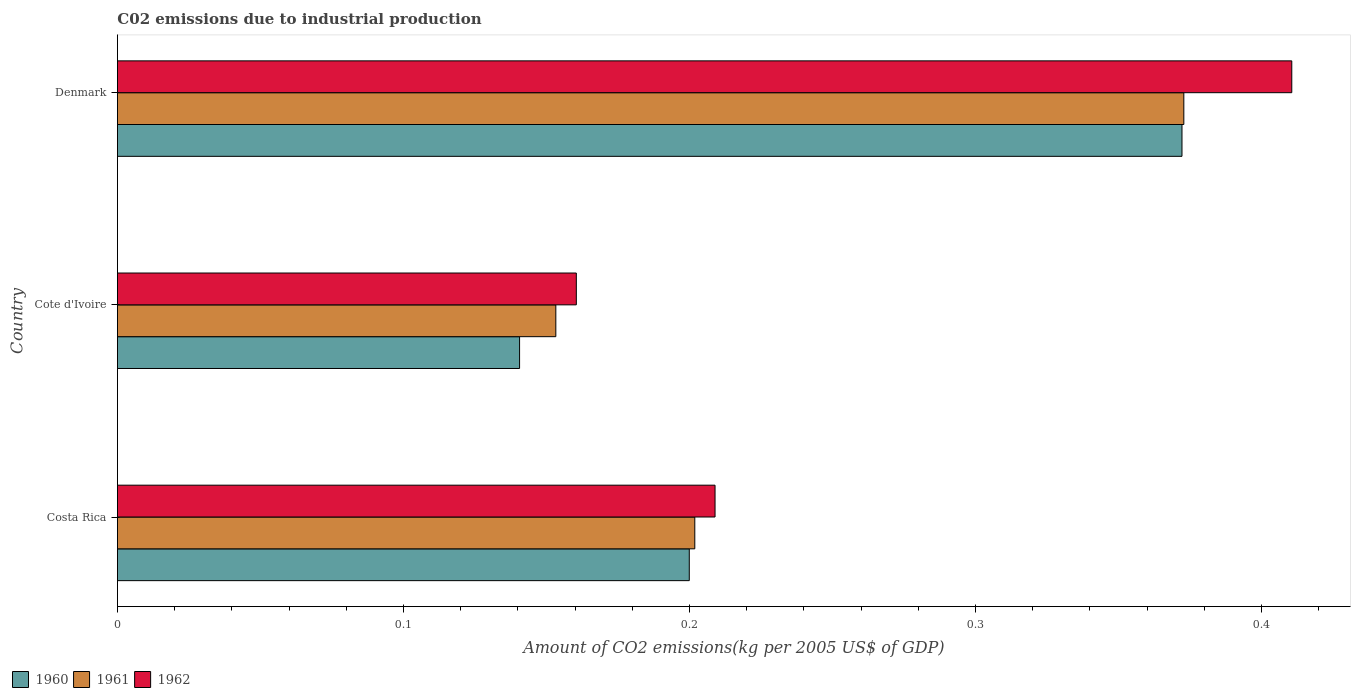How many different coloured bars are there?
Your response must be concise. 3. How many bars are there on the 1st tick from the top?
Ensure brevity in your answer.  3. In how many cases, is the number of bars for a given country not equal to the number of legend labels?
Ensure brevity in your answer.  0. What is the amount of CO2 emitted due to industrial production in 1962 in Cote d'Ivoire?
Make the answer very short. 0.16. Across all countries, what is the maximum amount of CO2 emitted due to industrial production in 1962?
Ensure brevity in your answer.  0.41. Across all countries, what is the minimum amount of CO2 emitted due to industrial production in 1960?
Your answer should be compact. 0.14. In which country was the amount of CO2 emitted due to industrial production in 1962 minimum?
Your response must be concise. Cote d'Ivoire. What is the total amount of CO2 emitted due to industrial production in 1960 in the graph?
Provide a short and direct response. 0.71. What is the difference between the amount of CO2 emitted due to industrial production in 1960 in Costa Rica and that in Denmark?
Provide a short and direct response. -0.17. What is the difference between the amount of CO2 emitted due to industrial production in 1960 in Cote d'Ivoire and the amount of CO2 emitted due to industrial production in 1962 in Costa Rica?
Offer a terse response. -0.07. What is the average amount of CO2 emitted due to industrial production in 1960 per country?
Your answer should be very brief. 0.24. What is the difference between the amount of CO2 emitted due to industrial production in 1962 and amount of CO2 emitted due to industrial production in 1960 in Denmark?
Offer a very short reply. 0.04. What is the ratio of the amount of CO2 emitted due to industrial production in 1960 in Cote d'Ivoire to that in Denmark?
Make the answer very short. 0.38. Is the difference between the amount of CO2 emitted due to industrial production in 1962 in Costa Rica and Denmark greater than the difference between the amount of CO2 emitted due to industrial production in 1960 in Costa Rica and Denmark?
Provide a succinct answer. No. What is the difference between the highest and the second highest amount of CO2 emitted due to industrial production in 1961?
Make the answer very short. 0.17. What is the difference between the highest and the lowest amount of CO2 emitted due to industrial production in 1960?
Your answer should be compact. 0.23. In how many countries, is the amount of CO2 emitted due to industrial production in 1960 greater than the average amount of CO2 emitted due to industrial production in 1960 taken over all countries?
Provide a succinct answer. 1. Is it the case that in every country, the sum of the amount of CO2 emitted due to industrial production in 1960 and amount of CO2 emitted due to industrial production in 1961 is greater than the amount of CO2 emitted due to industrial production in 1962?
Offer a terse response. Yes. How many bars are there?
Ensure brevity in your answer.  9. How many countries are there in the graph?
Give a very brief answer. 3. What is the difference between two consecutive major ticks on the X-axis?
Your response must be concise. 0.1. Does the graph contain any zero values?
Offer a very short reply. No. Does the graph contain grids?
Offer a very short reply. No. Where does the legend appear in the graph?
Provide a short and direct response. Bottom left. How are the legend labels stacked?
Ensure brevity in your answer.  Horizontal. What is the title of the graph?
Provide a short and direct response. C02 emissions due to industrial production. Does "1971" appear as one of the legend labels in the graph?
Give a very brief answer. No. What is the label or title of the X-axis?
Ensure brevity in your answer.  Amount of CO2 emissions(kg per 2005 US$ of GDP). What is the label or title of the Y-axis?
Make the answer very short. Country. What is the Amount of CO2 emissions(kg per 2005 US$ of GDP) of 1960 in Costa Rica?
Provide a succinct answer. 0.2. What is the Amount of CO2 emissions(kg per 2005 US$ of GDP) in 1961 in Costa Rica?
Your answer should be compact. 0.2. What is the Amount of CO2 emissions(kg per 2005 US$ of GDP) in 1962 in Costa Rica?
Your response must be concise. 0.21. What is the Amount of CO2 emissions(kg per 2005 US$ of GDP) in 1960 in Cote d'Ivoire?
Make the answer very short. 0.14. What is the Amount of CO2 emissions(kg per 2005 US$ of GDP) in 1961 in Cote d'Ivoire?
Your answer should be compact. 0.15. What is the Amount of CO2 emissions(kg per 2005 US$ of GDP) of 1962 in Cote d'Ivoire?
Keep it short and to the point. 0.16. What is the Amount of CO2 emissions(kg per 2005 US$ of GDP) of 1960 in Denmark?
Offer a terse response. 0.37. What is the Amount of CO2 emissions(kg per 2005 US$ of GDP) of 1961 in Denmark?
Your response must be concise. 0.37. What is the Amount of CO2 emissions(kg per 2005 US$ of GDP) in 1962 in Denmark?
Make the answer very short. 0.41. Across all countries, what is the maximum Amount of CO2 emissions(kg per 2005 US$ of GDP) of 1960?
Offer a very short reply. 0.37. Across all countries, what is the maximum Amount of CO2 emissions(kg per 2005 US$ of GDP) of 1961?
Give a very brief answer. 0.37. Across all countries, what is the maximum Amount of CO2 emissions(kg per 2005 US$ of GDP) in 1962?
Offer a very short reply. 0.41. Across all countries, what is the minimum Amount of CO2 emissions(kg per 2005 US$ of GDP) in 1960?
Ensure brevity in your answer.  0.14. Across all countries, what is the minimum Amount of CO2 emissions(kg per 2005 US$ of GDP) of 1961?
Provide a succinct answer. 0.15. Across all countries, what is the minimum Amount of CO2 emissions(kg per 2005 US$ of GDP) of 1962?
Provide a succinct answer. 0.16. What is the total Amount of CO2 emissions(kg per 2005 US$ of GDP) of 1960 in the graph?
Give a very brief answer. 0.71. What is the total Amount of CO2 emissions(kg per 2005 US$ of GDP) of 1961 in the graph?
Keep it short and to the point. 0.73. What is the total Amount of CO2 emissions(kg per 2005 US$ of GDP) of 1962 in the graph?
Offer a very short reply. 0.78. What is the difference between the Amount of CO2 emissions(kg per 2005 US$ of GDP) of 1960 in Costa Rica and that in Cote d'Ivoire?
Provide a succinct answer. 0.06. What is the difference between the Amount of CO2 emissions(kg per 2005 US$ of GDP) in 1961 in Costa Rica and that in Cote d'Ivoire?
Provide a short and direct response. 0.05. What is the difference between the Amount of CO2 emissions(kg per 2005 US$ of GDP) of 1962 in Costa Rica and that in Cote d'Ivoire?
Your answer should be very brief. 0.05. What is the difference between the Amount of CO2 emissions(kg per 2005 US$ of GDP) of 1960 in Costa Rica and that in Denmark?
Ensure brevity in your answer.  -0.17. What is the difference between the Amount of CO2 emissions(kg per 2005 US$ of GDP) of 1961 in Costa Rica and that in Denmark?
Keep it short and to the point. -0.17. What is the difference between the Amount of CO2 emissions(kg per 2005 US$ of GDP) of 1962 in Costa Rica and that in Denmark?
Make the answer very short. -0.2. What is the difference between the Amount of CO2 emissions(kg per 2005 US$ of GDP) in 1960 in Cote d'Ivoire and that in Denmark?
Your answer should be very brief. -0.23. What is the difference between the Amount of CO2 emissions(kg per 2005 US$ of GDP) in 1961 in Cote d'Ivoire and that in Denmark?
Make the answer very short. -0.22. What is the difference between the Amount of CO2 emissions(kg per 2005 US$ of GDP) in 1962 in Cote d'Ivoire and that in Denmark?
Your answer should be very brief. -0.25. What is the difference between the Amount of CO2 emissions(kg per 2005 US$ of GDP) in 1960 in Costa Rica and the Amount of CO2 emissions(kg per 2005 US$ of GDP) in 1961 in Cote d'Ivoire?
Provide a short and direct response. 0.05. What is the difference between the Amount of CO2 emissions(kg per 2005 US$ of GDP) in 1960 in Costa Rica and the Amount of CO2 emissions(kg per 2005 US$ of GDP) in 1962 in Cote d'Ivoire?
Provide a succinct answer. 0.04. What is the difference between the Amount of CO2 emissions(kg per 2005 US$ of GDP) of 1961 in Costa Rica and the Amount of CO2 emissions(kg per 2005 US$ of GDP) of 1962 in Cote d'Ivoire?
Give a very brief answer. 0.04. What is the difference between the Amount of CO2 emissions(kg per 2005 US$ of GDP) in 1960 in Costa Rica and the Amount of CO2 emissions(kg per 2005 US$ of GDP) in 1961 in Denmark?
Give a very brief answer. -0.17. What is the difference between the Amount of CO2 emissions(kg per 2005 US$ of GDP) in 1960 in Costa Rica and the Amount of CO2 emissions(kg per 2005 US$ of GDP) in 1962 in Denmark?
Provide a succinct answer. -0.21. What is the difference between the Amount of CO2 emissions(kg per 2005 US$ of GDP) of 1961 in Costa Rica and the Amount of CO2 emissions(kg per 2005 US$ of GDP) of 1962 in Denmark?
Offer a very short reply. -0.21. What is the difference between the Amount of CO2 emissions(kg per 2005 US$ of GDP) of 1960 in Cote d'Ivoire and the Amount of CO2 emissions(kg per 2005 US$ of GDP) of 1961 in Denmark?
Provide a short and direct response. -0.23. What is the difference between the Amount of CO2 emissions(kg per 2005 US$ of GDP) of 1960 in Cote d'Ivoire and the Amount of CO2 emissions(kg per 2005 US$ of GDP) of 1962 in Denmark?
Offer a terse response. -0.27. What is the difference between the Amount of CO2 emissions(kg per 2005 US$ of GDP) of 1961 in Cote d'Ivoire and the Amount of CO2 emissions(kg per 2005 US$ of GDP) of 1962 in Denmark?
Give a very brief answer. -0.26. What is the average Amount of CO2 emissions(kg per 2005 US$ of GDP) in 1960 per country?
Offer a terse response. 0.24. What is the average Amount of CO2 emissions(kg per 2005 US$ of GDP) of 1961 per country?
Your answer should be compact. 0.24. What is the average Amount of CO2 emissions(kg per 2005 US$ of GDP) in 1962 per country?
Your response must be concise. 0.26. What is the difference between the Amount of CO2 emissions(kg per 2005 US$ of GDP) of 1960 and Amount of CO2 emissions(kg per 2005 US$ of GDP) of 1961 in Costa Rica?
Offer a very short reply. -0. What is the difference between the Amount of CO2 emissions(kg per 2005 US$ of GDP) in 1960 and Amount of CO2 emissions(kg per 2005 US$ of GDP) in 1962 in Costa Rica?
Keep it short and to the point. -0.01. What is the difference between the Amount of CO2 emissions(kg per 2005 US$ of GDP) in 1961 and Amount of CO2 emissions(kg per 2005 US$ of GDP) in 1962 in Costa Rica?
Keep it short and to the point. -0.01. What is the difference between the Amount of CO2 emissions(kg per 2005 US$ of GDP) of 1960 and Amount of CO2 emissions(kg per 2005 US$ of GDP) of 1961 in Cote d'Ivoire?
Your response must be concise. -0.01. What is the difference between the Amount of CO2 emissions(kg per 2005 US$ of GDP) of 1960 and Amount of CO2 emissions(kg per 2005 US$ of GDP) of 1962 in Cote d'Ivoire?
Provide a succinct answer. -0.02. What is the difference between the Amount of CO2 emissions(kg per 2005 US$ of GDP) of 1961 and Amount of CO2 emissions(kg per 2005 US$ of GDP) of 1962 in Cote d'Ivoire?
Offer a very short reply. -0.01. What is the difference between the Amount of CO2 emissions(kg per 2005 US$ of GDP) in 1960 and Amount of CO2 emissions(kg per 2005 US$ of GDP) in 1961 in Denmark?
Your response must be concise. -0. What is the difference between the Amount of CO2 emissions(kg per 2005 US$ of GDP) in 1960 and Amount of CO2 emissions(kg per 2005 US$ of GDP) in 1962 in Denmark?
Provide a succinct answer. -0.04. What is the difference between the Amount of CO2 emissions(kg per 2005 US$ of GDP) in 1961 and Amount of CO2 emissions(kg per 2005 US$ of GDP) in 1962 in Denmark?
Ensure brevity in your answer.  -0.04. What is the ratio of the Amount of CO2 emissions(kg per 2005 US$ of GDP) in 1960 in Costa Rica to that in Cote d'Ivoire?
Your response must be concise. 1.42. What is the ratio of the Amount of CO2 emissions(kg per 2005 US$ of GDP) of 1961 in Costa Rica to that in Cote d'Ivoire?
Your response must be concise. 1.32. What is the ratio of the Amount of CO2 emissions(kg per 2005 US$ of GDP) in 1962 in Costa Rica to that in Cote d'Ivoire?
Ensure brevity in your answer.  1.3. What is the ratio of the Amount of CO2 emissions(kg per 2005 US$ of GDP) of 1960 in Costa Rica to that in Denmark?
Offer a terse response. 0.54. What is the ratio of the Amount of CO2 emissions(kg per 2005 US$ of GDP) of 1961 in Costa Rica to that in Denmark?
Ensure brevity in your answer.  0.54. What is the ratio of the Amount of CO2 emissions(kg per 2005 US$ of GDP) of 1962 in Costa Rica to that in Denmark?
Your answer should be very brief. 0.51. What is the ratio of the Amount of CO2 emissions(kg per 2005 US$ of GDP) in 1960 in Cote d'Ivoire to that in Denmark?
Ensure brevity in your answer.  0.38. What is the ratio of the Amount of CO2 emissions(kg per 2005 US$ of GDP) of 1961 in Cote d'Ivoire to that in Denmark?
Keep it short and to the point. 0.41. What is the ratio of the Amount of CO2 emissions(kg per 2005 US$ of GDP) in 1962 in Cote d'Ivoire to that in Denmark?
Your answer should be very brief. 0.39. What is the difference between the highest and the second highest Amount of CO2 emissions(kg per 2005 US$ of GDP) in 1960?
Provide a succinct answer. 0.17. What is the difference between the highest and the second highest Amount of CO2 emissions(kg per 2005 US$ of GDP) in 1961?
Your answer should be very brief. 0.17. What is the difference between the highest and the second highest Amount of CO2 emissions(kg per 2005 US$ of GDP) in 1962?
Make the answer very short. 0.2. What is the difference between the highest and the lowest Amount of CO2 emissions(kg per 2005 US$ of GDP) in 1960?
Provide a short and direct response. 0.23. What is the difference between the highest and the lowest Amount of CO2 emissions(kg per 2005 US$ of GDP) in 1961?
Offer a very short reply. 0.22. What is the difference between the highest and the lowest Amount of CO2 emissions(kg per 2005 US$ of GDP) in 1962?
Provide a short and direct response. 0.25. 